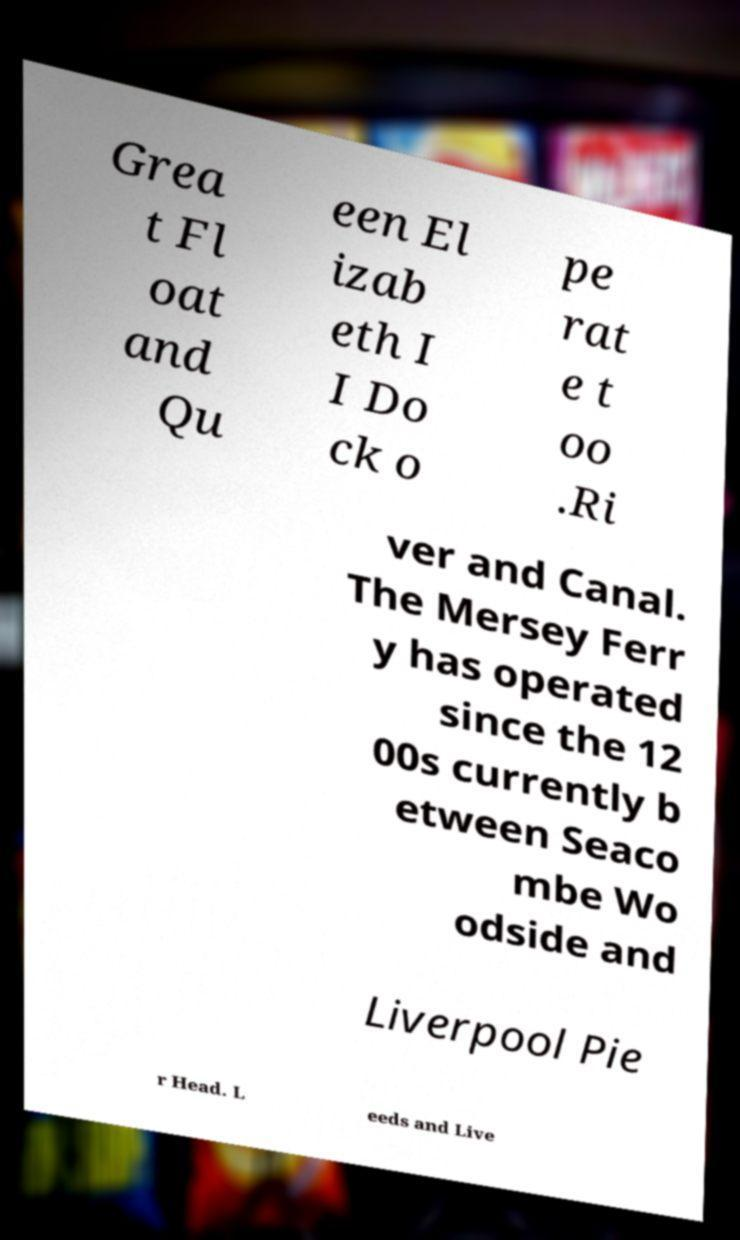Could you extract and type out the text from this image? Grea t Fl oat and Qu een El izab eth I I Do ck o pe rat e t oo .Ri ver and Canal. The Mersey Ferr y has operated since the 12 00s currently b etween Seaco mbe Wo odside and Liverpool Pie r Head. L eeds and Live 